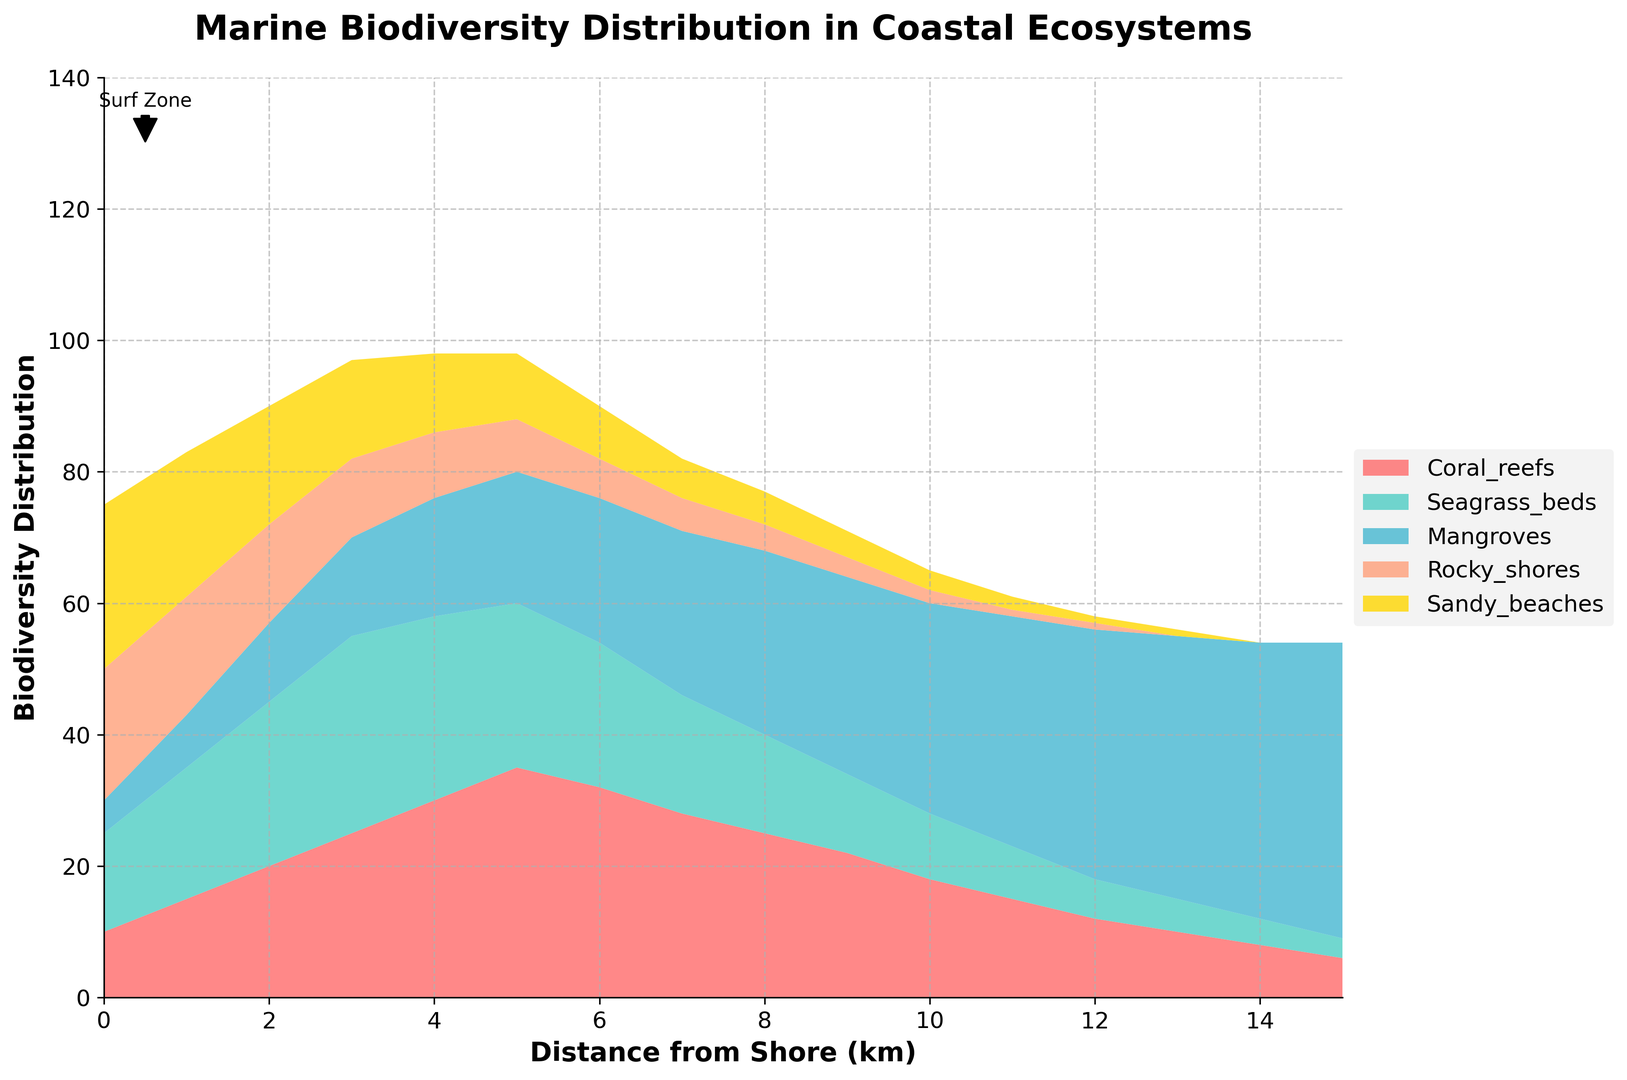Which coastal ecosystem has the highest biodiversity at the shore (0 km)? At the shore (0 km), the heights of the segments representing different ecosystems are: Coral Reefs 10, Seagrass Beds 15, Mangroves 5, Rocky Shores 20, and Sandy Beaches 25. The tallest segment represents the ecosystem with the highest biodiversity.
Answer: Sandy Beaches What is the sum of the biodiversity values for Coral Reefs and Mangroves at 5 km from the shore? At 5 km from the shore, the biodiversity values are: Coral Reefs 35 and Mangroves 20. Adding these values yields 35 + 20 = 55.
Answer: 55 How does the biodiversity distribution for Mangroves change as you move from 0 km to 10 km from the shore? The biodiversity values for Mangroves at each kilometer from 0 to 10 km are: 0 km: 5, 1 km: 8, 2 km: 12, 3 km: 15, 4 km: 18, 5 km: 20, 6 km: 22, 7 km: 25, 8 km: 28, 9 km: 30, 10 km: 32. It shows a steady increase over this range.
Answer: Steady increase Between Seagrass Beds and Rocky Shores, which ecosystem shows a higher biodiversity at 7 km from the shore? At 7 km from the shore, the biodiversity values are: Seagrass Beds 18 and Rocky Shores 5. Comparing these values, Seagrass Beds have a higher biodiversity.
Answer: Seagrass Beds Which two ecosystems have declining biodiversity as the distance from the shore increases from 0 km to 15 km? Observing the chart, as the distance from the shore increases from 0 to 15 km, the ecosystems with declining biodiversity values over this range are Rocky Shores and Sandy Beaches.
Answer: Rocky Shores and Sandy Beaches At what distance from the shore does Mangroves biodiversity surpass Seagrass Beds biodiversity? Visualizing the overlaying segments of Mangroves and Seagrass Beds, Mangroves biodiversity first surpasses Seagrass Beds at 6 km from the shore where Mangroves exceed Seagrass Beds.
Answer: 6 km What is the average biodiversity for Coral Reefs between 5 km and 10 km from the shore? Biodiversity values for Coral Reefs from 5 km to 10 km are: 5 km: 35, 6 km: 32, 7 km: 28, 8 km: 25, 9 km: 22, 10 km: 18. Sum these values: 35 + 32 + 28 + 25 + 22 + 18 = 160. There are 6 values, so the average is 160 / 6 = 26.67.
Answer: 26.67 Where is the highest biodiversity value distinct for Seagrass Beds located along the distance from shore? Looking at the stacked area, the highest segment for Seagrass Beds appears at 3 km from the shore.
Answer: 3 km Which ecosystem shows almost constant biodiversity near the shore (up to 3 km)? Evaluating the chart, Coral Reefs' biodiversity shows relatively consistent values near the shore (10, 15, 20, 25 for the first 4 km) compared to others.
Answer: Coral Reefs When does Mangroves achieve its peak value, and what is that value? The biodiversity value for Mangroves reaches its peak at 15 km from the shore with a value of 45.
Answer: 15 km, 45 